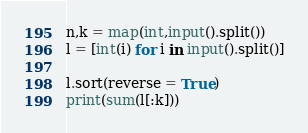<code> <loc_0><loc_0><loc_500><loc_500><_Python_>n,k = map(int,input().split())
l = [int(i) for i in input().split()]

l.sort(reverse = True)
print(sum(l[:k]))</code> 